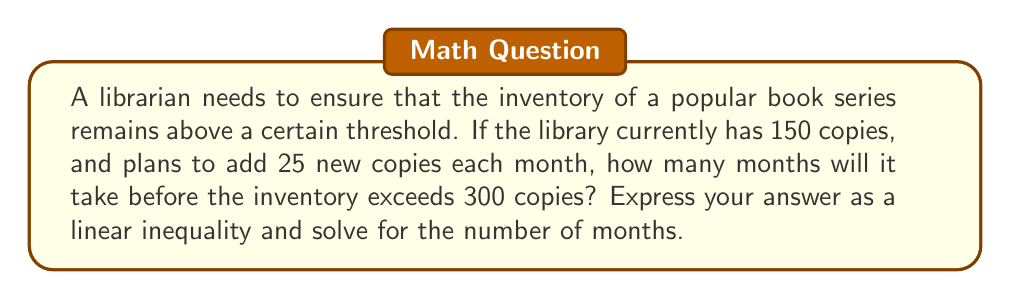Can you solve this math problem? Let's approach this step-by-step:

1. Define the variable:
   Let $x$ be the number of months.

2. Set up the inequality:
   Initial inventory + (Monthly addition × Number of months) > Target inventory
   $150 + 25x > 300$

3. Subtract 150 from both sides:
   $25x > 150$

4. Divide both sides by 25:
   $x > 6$

5. Since $x$ represents the number of months, which must be a whole number, we need to round up to the next integer.

6. Therefore, the inventory will exceed 300 copies after the 7th month.

To verify:
After 6 months: $150 + (25 × 6) = 300$
After 7 months: $150 + (25 × 7) = 325$ (which exceeds 300)
Answer: $x > 6$, so 7 months 